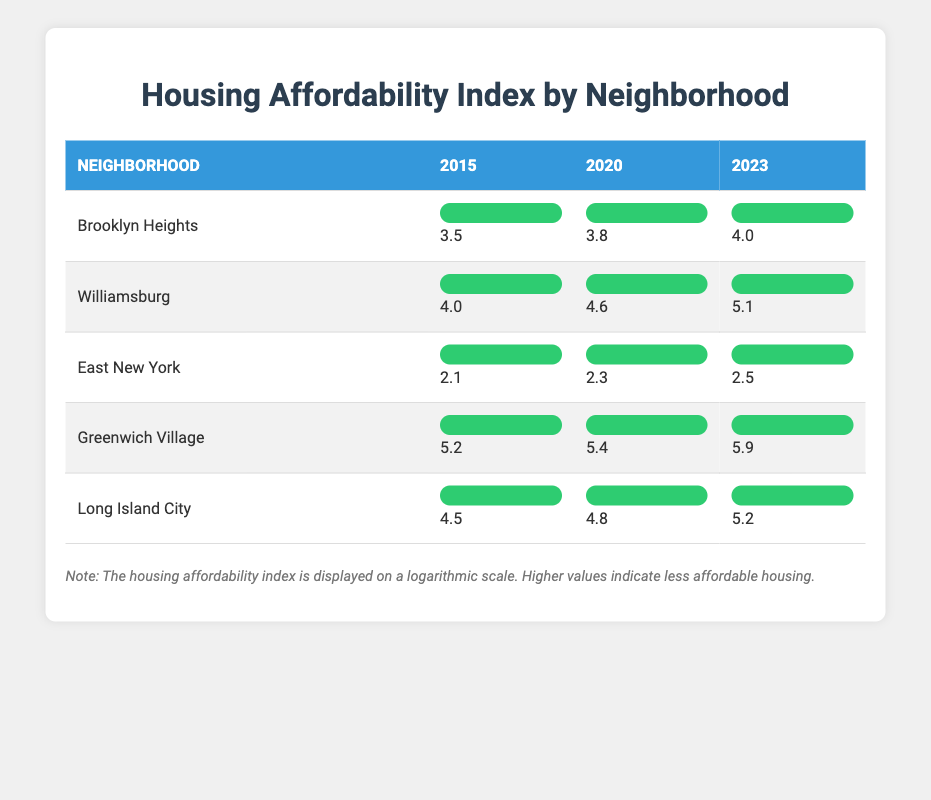What was the housing affordability index for Williamsburg in 2020? The table shows that Williamsburg has an affordability index of 4.6 for the year 2020.
Answer: 4.6 Which neighborhood has the highest affordability index in 2023? By looking at the year 2023, Greenwich Village has the highest index of 5.9 compared to other neighborhoods.
Answer: Greenwich Village What was the increase in the housing affordability index for Brooklyn Heights from 2015 to 2023? The index for Brooklyn Heights was 3.5 in 2015 and increased to 4.0 in 2023. Therefore, the increase is 4.0 - 3.5 = 0.5.
Answer: 0.5 Is the affordability index for East New York increasing over the years? The index values are 2.1 in 2015, 2.3 in 2020, and 2.5 in 2023, which shows a consistent increase over the years.
Answer: Yes What is the average housing affordability index for Long Island City over the years? The indices for Long Island City are 4.5 (2015), 4.8 (2020), and 5.2 (2023). The average is calculated as (4.5 + 4.8 + 5.2) / 3 = 14.5 / 3 = 4.83.
Answer: 4.83 Which neighborhood experienced the least change in its affordability index from 2015 to 2023? Comparing the indices, East New York shows the least change: 2.1 (2015) to 2.5 (2023), which is an increase of 0.4. The others had larger changes.
Answer: East New York What is the total difference in the affordability index between the highest and lowest neighborhoods in 2023? In 2023, Greenwich Village has an index of 5.9 and East New York has 2.5. The difference is 5.9 - 2.5 = 3.4.
Answer: 3.4 Did Williamsburg have the highest affordability index in any of the years listed? Checking the indices, Williamsburg had the highest index in 2023 with 5.1, but it was lower than Greenwich Village in 2020 and 2023. Thus, it was not the highest overall.
Answer: No 